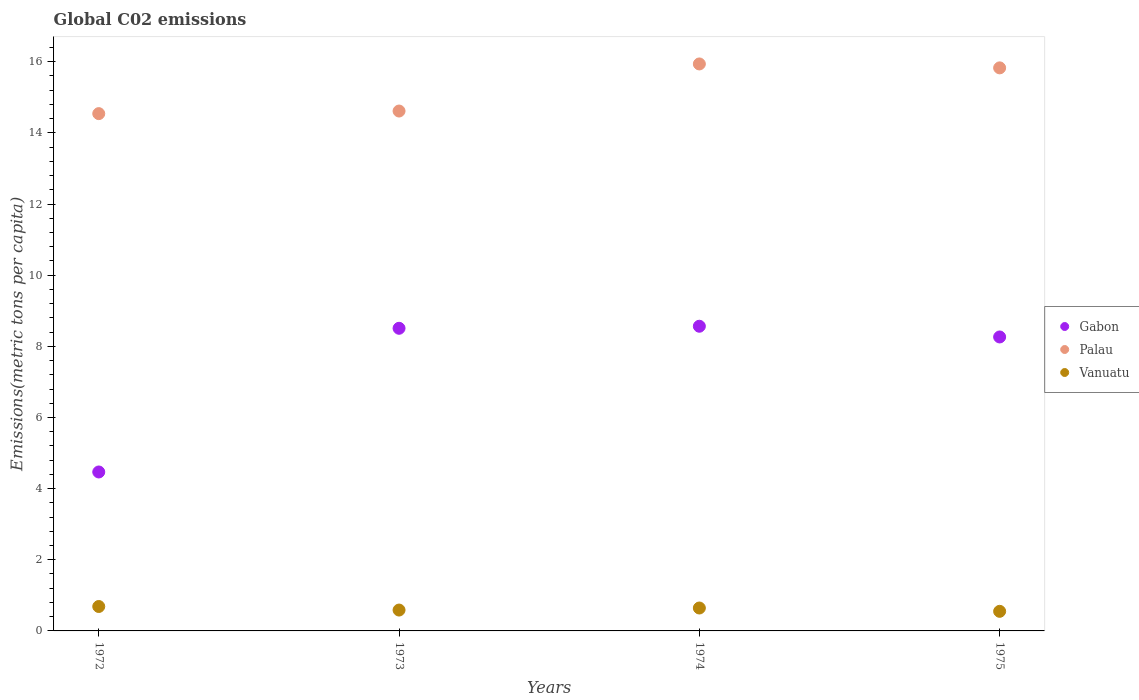How many different coloured dotlines are there?
Make the answer very short. 3. What is the amount of CO2 emitted in in Gabon in 1974?
Provide a short and direct response. 8.56. Across all years, what is the maximum amount of CO2 emitted in in Vanuatu?
Your answer should be compact. 0.69. Across all years, what is the minimum amount of CO2 emitted in in Vanuatu?
Provide a succinct answer. 0.55. In which year was the amount of CO2 emitted in in Palau maximum?
Provide a succinct answer. 1974. In which year was the amount of CO2 emitted in in Vanuatu minimum?
Ensure brevity in your answer.  1975. What is the total amount of CO2 emitted in in Palau in the graph?
Provide a succinct answer. 60.92. What is the difference between the amount of CO2 emitted in in Vanuatu in 1972 and that in 1975?
Give a very brief answer. 0.14. What is the difference between the amount of CO2 emitted in in Gabon in 1973 and the amount of CO2 emitted in in Vanuatu in 1972?
Keep it short and to the point. 7.82. What is the average amount of CO2 emitted in in Palau per year?
Your response must be concise. 15.23. In the year 1972, what is the difference between the amount of CO2 emitted in in Vanuatu and amount of CO2 emitted in in Gabon?
Keep it short and to the point. -3.78. What is the ratio of the amount of CO2 emitted in in Vanuatu in 1972 to that in 1975?
Your answer should be compact. 1.25. Is the amount of CO2 emitted in in Palau in 1972 less than that in 1973?
Provide a succinct answer. Yes. Is the difference between the amount of CO2 emitted in in Vanuatu in 1972 and 1974 greater than the difference between the amount of CO2 emitted in in Gabon in 1972 and 1974?
Your answer should be very brief. Yes. What is the difference between the highest and the second highest amount of CO2 emitted in in Vanuatu?
Provide a short and direct response. 0.04. What is the difference between the highest and the lowest amount of CO2 emitted in in Palau?
Give a very brief answer. 1.4. Is the sum of the amount of CO2 emitted in in Palau in 1973 and 1974 greater than the maximum amount of CO2 emitted in in Gabon across all years?
Ensure brevity in your answer.  Yes. Is it the case that in every year, the sum of the amount of CO2 emitted in in Palau and amount of CO2 emitted in in Gabon  is greater than the amount of CO2 emitted in in Vanuatu?
Provide a short and direct response. Yes. Does the amount of CO2 emitted in in Vanuatu monotonically increase over the years?
Make the answer very short. No. Is the amount of CO2 emitted in in Vanuatu strictly greater than the amount of CO2 emitted in in Palau over the years?
Provide a succinct answer. No. Is the amount of CO2 emitted in in Gabon strictly less than the amount of CO2 emitted in in Palau over the years?
Your answer should be very brief. Yes. How many dotlines are there?
Keep it short and to the point. 3. How many years are there in the graph?
Provide a short and direct response. 4. Does the graph contain any zero values?
Provide a succinct answer. No. Where does the legend appear in the graph?
Your answer should be compact. Center right. How are the legend labels stacked?
Provide a succinct answer. Vertical. What is the title of the graph?
Your answer should be compact. Global C02 emissions. Does "Senegal" appear as one of the legend labels in the graph?
Ensure brevity in your answer.  No. What is the label or title of the X-axis?
Provide a short and direct response. Years. What is the label or title of the Y-axis?
Keep it short and to the point. Emissions(metric tons per capita). What is the Emissions(metric tons per capita) in Gabon in 1972?
Ensure brevity in your answer.  4.47. What is the Emissions(metric tons per capita) of Palau in 1972?
Offer a terse response. 14.54. What is the Emissions(metric tons per capita) in Vanuatu in 1972?
Ensure brevity in your answer.  0.69. What is the Emissions(metric tons per capita) of Gabon in 1973?
Offer a terse response. 8.51. What is the Emissions(metric tons per capita) in Palau in 1973?
Your response must be concise. 14.61. What is the Emissions(metric tons per capita) in Vanuatu in 1973?
Keep it short and to the point. 0.59. What is the Emissions(metric tons per capita) in Gabon in 1974?
Provide a succinct answer. 8.56. What is the Emissions(metric tons per capita) of Palau in 1974?
Your answer should be very brief. 15.94. What is the Emissions(metric tons per capita) of Vanuatu in 1974?
Keep it short and to the point. 0.64. What is the Emissions(metric tons per capita) in Gabon in 1975?
Your answer should be compact. 8.26. What is the Emissions(metric tons per capita) in Palau in 1975?
Give a very brief answer. 15.83. What is the Emissions(metric tons per capita) of Vanuatu in 1975?
Your response must be concise. 0.55. Across all years, what is the maximum Emissions(metric tons per capita) of Gabon?
Offer a very short reply. 8.56. Across all years, what is the maximum Emissions(metric tons per capita) of Palau?
Your answer should be very brief. 15.94. Across all years, what is the maximum Emissions(metric tons per capita) of Vanuatu?
Give a very brief answer. 0.69. Across all years, what is the minimum Emissions(metric tons per capita) of Gabon?
Offer a terse response. 4.47. Across all years, what is the minimum Emissions(metric tons per capita) of Palau?
Provide a short and direct response. 14.54. Across all years, what is the minimum Emissions(metric tons per capita) of Vanuatu?
Keep it short and to the point. 0.55. What is the total Emissions(metric tons per capita) of Gabon in the graph?
Offer a very short reply. 29.8. What is the total Emissions(metric tons per capita) in Palau in the graph?
Offer a very short reply. 60.92. What is the total Emissions(metric tons per capita) in Vanuatu in the graph?
Ensure brevity in your answer.  2.47. What is the difference between the Emissions(metric tons per capita) of Gabon in 1972 and that in 1973?
Ensure brevity in your answer.  -4.04. What is the difference between the Emissions(metric tons per capita) in Palau in 1972 and that in 1973?
Your response must be concise. -0.07. What is the difference between the Emissions(metric tons per capita) of Vanuatu in 1972 and that in 1973?
Make the answer very short. 0.1. What is the difference between the Emissions(metric tons per capita) in Gabon in 1972 and that in 1974?
Offer a terse response. -4.1. What is the difference between the Emissions(metric tons per capita) of Palau in 1972 and that in 1974?
Ensure brevity in your answer.  -1.4. What is the difference between the Emissions(metric tons per capita) of Vanuatu in 1972 and that in 1974?
Ensure brevity in your answer.  0.04. What is the difference between the Emissions(metric tons per capita) of Gabon in 1972 and that in 1975?
Keep it short and to the point. -3.8. What is the difference between the Emissions(metric tons per capita) in Palau in 1972 and that in 1975?
Offer a terse response. -1.29. What is the difference between the Emissions(metric tons per capita) of Vanuatu in 1972 and that in 1975?
Offer a very short reply. 0.14. What is the difference between the Emissions(metric tons per capita) in Gabon in 1973 and that in 1974?
Your response must be concise. -0.06. What is the difference between the Emissions(metric tons per capita) of Palau in 1973 and that in 1974?
Your answer should be very brief. -1.32. What is the difference between the Emissions(metric tons per capita) of Vanuatu in 1973 and that in 1974?
Provide a short and direct response. -0.06. What is the difference between the Emissions(metric tons per capita) in Gabon in 1973 and that in 1975?
Provide a short and direct response. 0.24. What is the difference between the Emissions(metric tons per capita) in Palau in 1973 and that in 1975?
Your answer should be very brief. -1.21. What is the difference between the Emissions(metric tons per capita) in Vanuatu in 1973 and that in 1975?
Give a very brief answer. 0.04. What is the difference between the Emissions(metric tons per capita) in Gabon in 1974 and that in 1975?
Make the answer very short. 0.3. What is the difference between the Emissions(metric tons per capita) of Palau in 1974 and that in 1975?
Provide a succinct answer. 0.11. What is the difference between the Emissions(metric tons per capita) of Vanuatu in 1974 and that in 1975?
Your response must be concise. 0.09. What is the difference between the Emissions(metric tons per capita) in Gabon in 1972 and the Emissions(metric tons per capita) in Palau in 1973?
Ensure brevity in your answer.  -10.15. What is the difference between the Emissions(metric tons per capita) of Gabon in 1972 and the Emissions(metric tons per capita) of Vanuatu in 1973?
Offer a very short reply. 3.88. What is the difference between the Emissions(metric tons per capita) of Palau in 1972 and the Emissions(metric tons per capita) of Vanuatu in 1973?
Your answer should be very brief. 13.95. What is the difference between the Emissions(metric tons per capita) in Gabon in 1972 and the Emissions(metric tons per capita) in Palau in 1974?
Offer a very short reply. -11.47. What is the difference between the Emissions(metric tons per capita) in Gabon in 1972 and the Emissions(metric tons per capita) in Vanuatu in 1974?
Offer a very short reply. 3.82. What is the difference between the Emissions(metric tons per capita) of Palau in 1972 and the Emissions(metric tons per capita) of Vanuatu in 1974?
Give a very brief answer. 13.9. What is the difference between the Emissions(metric tons per capita) of Gabon in 1972 and the Emissions(metric tons per capita) of Palau in 1975?
Offer a terse response. -11.36. What is the difference between the Emissions(metric tons per capita) of Gabon in 1972 and the Emissions(metric tons per capita) of Vanuatu in 1975?
Offer a very short reply. 3.92. What is the difference between the Emissions(metric tons per capita) in Palau in 1972 and the Emissions(metric tons per capita) in Vanuatu in 1975?
Offer a very short reply. 13.99. What is the difference between the Emissions(metric tons per capita) in Gabon in 1973 and the Emissions(metric tons per capita) in Palau in 1974?
Your response must be concise. -7.43. What is the difference between the Emissions(metric tons per capita) of Gabon in 1973 and the Emissions(metric tons per capita) of Vanuatu in 1974?
Your response must be concise. 7.86. What is the difference between the Emissions(metric tons per capita) in Palau in 1973 and the Emissions(metric tons per capita) in Vanuatu in 1974?
Your response must be concise. 13.97. What is the difference between the Emissions(metric tons per capita) of Gabon in 1973 and the Emissions(metric tons per capita) of Palau in 1975?
Give a very brief answer. -7.32. What is the difference between the Emissions(metric tons per capita) in Gabon in 1973 and the Emissions(metric tons per capita) in Vanuatu in 1975?
Ensure brevity in your answer.  7.96. What is the difference between the Emissions(metric tons per capita) in Palau in 1973 and the Emissions(metric tons per capita) in Vanuatu in 1975?
Make the answer very short. 14.06. What is the difference between the Emissions(metric tons per capita) of Gabon in 1974 and the Emissions(metric tons per capita) of Palau in 1975?
Offer a terse response. -7.26. What is the difference between the Emissions(metric tons per capita) in Gabon in 1974 and the Emissions(metric tons per capita) in Vanuatu in 1975?
Your answer should be compact. 8.01. What is the difference between the Emissions(metric tons per capita) of Palau in 1974 and the Emissions(metric tons per capita) of Vanuatu in 1975?
Keep it short and to the point. 15.39. What is the average Emissions(metric tons per capita) of Gabon per year?
Keep it short and to the point. 7.45. What is the average Emissions(metric tons per capita) in Palau per year?
Provide a short and direct response. 15.23. What is the average Emissions(metric tons per capita) of Vanuatu per year?
Make the answer very short. 0.62. In the year 1972, what is the difference between the Emissions(metric tons per capita) of Gabon and Emissions(metric tons per capita) of Palau?
Ensure brevity in your answer.  -10.07. In the year 1972, what is the difference between the Emissions(metric tons per capita) in Gabon and Emissions(metric tons per capita) in Vanuatu?
Give a very brief answer. 3.78. In the year 1972, what is the difference between the Emissions(metric tons per capita) of Palau and Emissions(metric tons per capita) of Vanuatu?
Keep it short and to the point. 13.85. In the year 1973, what is the difference between the Emissions(metric tons per capita) in Gabon and Emissions(metric tons per capita) in Palau?
Keep it short and to the point. -6.11. In the year 1973, what is the difference between the Emissions(metric tons per capita) in Gabon and Emissions(metric tons per capita) in Vanuatu?
Offer a terse response. 7.92. In the year 1973, what is the difference between the Emissions(metric tons per capita) in Palau and Emissions(metric tons per capita) in Vanuatu?
Your answer should be very brief. 14.03. In the year 1974, what is the difference between the Emissions(metric tons per capita) of Gabon and Emissions(metric tons per capita) of Palau?
Give a very brief answer. -7.37. In the year 1974, what is the difference between the Emissions(metric tons per capita) in Gabon and Emissions(metric tons per capita) in Vanuatu?
Offer a terse response. 7.92. In the year 1974, what is the difference between the Emissions(metric tons per capita) of Palau and Emissions(metric tons per capita) of Vanuatu?
Keep it short and to the point. 15.29. In the year 1975, what is the difference between the Emissions(metric tons per capita) in Gabon and Emissions(metric tons per capita) in Palau?
Offer a terse response. -7.56. In the year 1975, what is the difference between the Emissions(metric tons per capita) of Gabon and Emissions(metric tons per capita) of Vanuatu?
Your answer should be very brief. 7.71. In the year 1975, what is the difference between the Emissions(metric tons per capita) in Palau and Emissions(metric tons per capita) in Vanuatu?
Offer a very short reply. 15.28. What is the ratio of the Emissions(metric tons per capita) in Gabon in 1972 to that in 1973?
Provide a short and direct response. 0.53. What is the ratio of the Emissions(metric tons per capita) of Palau in 1972 to that in 1973?
Keep it short and to the point. 0.99. What is the ratio of the Emissions(metric tons per capita) in Vanuatu in 1972 to that in 1973?
Make the answer very short. 1.17. What is the ratio of the Emissions(metric tons per capita) in Gabon in 1972 to that in 1974?
Your answer should be compact. 0.52. What is the ratio of the Emissions(metric tons per capita) of Palau in 1972 to that in 1974?
Make the answer very short. 0.91. What is the ratio of the Emissions(metric tons per capita) of Vanuatu in 1972 to that in 1974?
Offer a terse response. 1.07. What is the ratio of the Emissions(metric tons per capita) in Gabon in 1972 to that in 1975?
Keep it short and to the point. 0.54. What is the ratio of the Emissions(metric tons per capita) in Palau in 1972 to that in 1975?
Give a very brief answer. 0.92. What is the ratio of the Emissions(metric tons per capita) of Vanuatu in 1972 to that in 1975?
Ensure brevity in your answer.  1.25. What is the ratio of the Emissions(metric tons per capita) of Gabon in 1973 to that in 1974?
Make the answer very short. 0.99. What is the ratio of the Emissions(metric tons per capita) of Palau in 1973 to that in 1974?
Offer a very short reply. 0.92. What is the ratio of the Emissions(metric tons per capita) in Vanuatu in 1973 to that in 1974?
Your answer should be compact. 0.91. What is the ratio of the Emissions(metric tons per capita) of Gabon in 1973 to that in 1975?
Your response must be concise. 1.03. What is the ratio of the Emissions(metric tons per capita) in Palau in 1973 to that in 1975?
Give a very brief answer. 0.92. What is the ratio of the Emissions(metric tons per capita) of Vanuatu in 1973 to that in 1975?
Your response must be concise. 1.07. What is the ratio of the Emissions(metric tons per capita) in Gabon in 1974 to that in 1975?
Offer a terse response. 1.04. What is the ratio of the Emissions(metric tons per capita) in Vanuatu in 1974 to that in 1975?
Offer a very short reply. 1.17. What is the difference between the highest and the second highest Emissions(metric tons per capita) in Gabon?
Make the answer very short. 0.06. What is the difference between the highest and the second highest Emissions(metric tons per capita) in Palau?
Your answer should be compact. 0.11. What is the difference between the highest and the second highest Emissions(metric tons per capita) in Vanuatu?
Offer a terse response. 0.04. What is the difference between the highest and the lowest Emissions(metric tons per capita) in Gabon?
Provide a succinct answer. 4.1. What is the difference between the highest and the lowest Emissions(metric tons per capita) of Palau?
Your answer should be compact. 1.4. What is the difference between the highest and the lowest Emissions(metric tons per capita) in Vanuatu?
Offer a terse response. 0.14. 